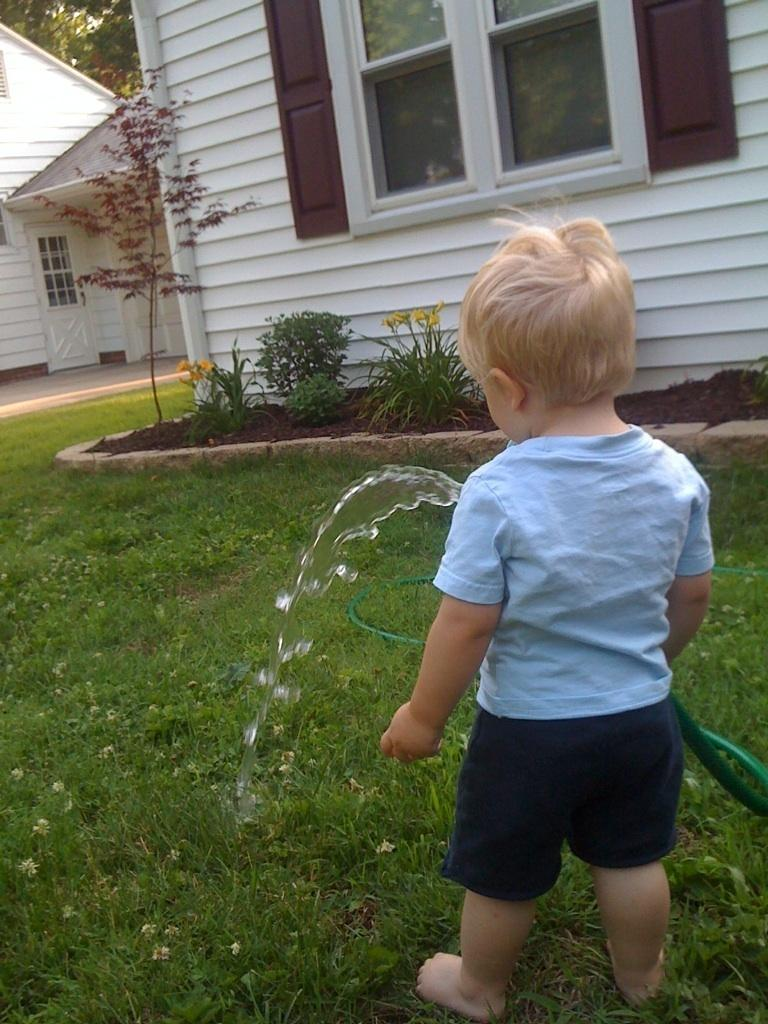What is the main subject in the foreground of the image? There is a boy in the foreground of the image. What is the boy doing in the image? The boy is watering the grass with a pipe. What can be seen in the background of the image? There are two houses in the background of the image. Are there any plants visible in the image? Yes, plants are placed on the side of the house. What type of locket is the boy holding in the image? There is no locket present in the image; the boy is holding a pipe to water the grass. 